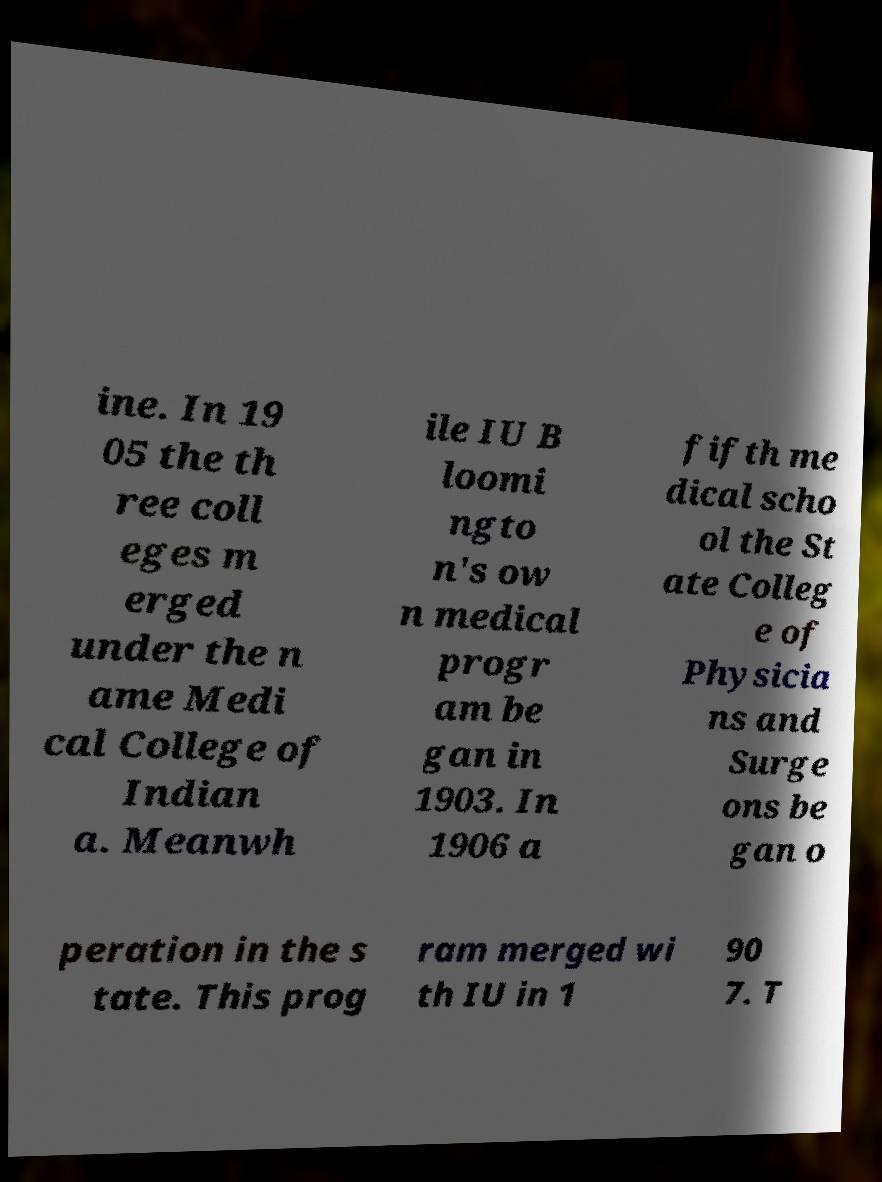Please read and relay the text visible in this image. What does it say? ine. In 19 05 the th ree coll eges m erged under the n ame Medi cal College of Indian a. Meanwh ile IU B loomi ngto n's ow n medical progr am be gan in 1903. In 1906 a fifth me dical scho ol the St ate Colleg e of Physicia ns and Surge ons be gan o peration in the s tate. This prog ram merged wi th IU in 1 90 7. T 